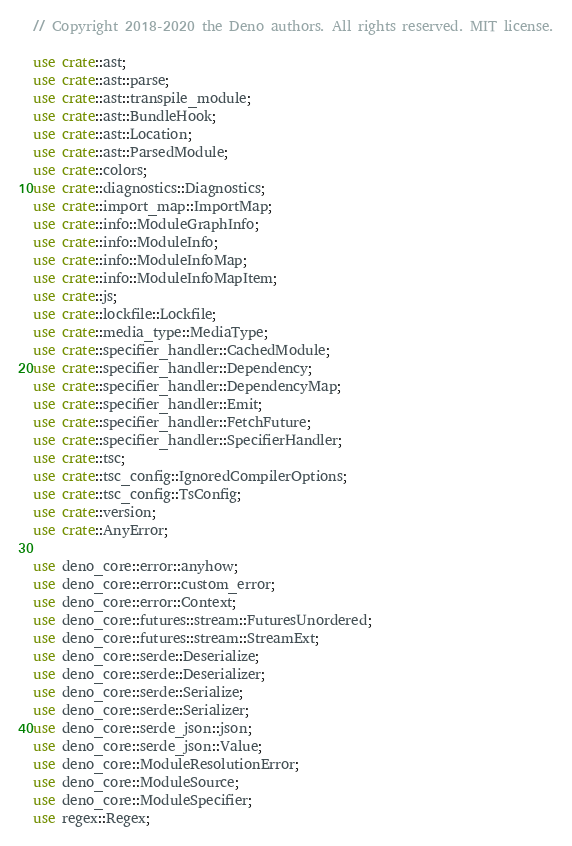Convert code to text. <code><loc_0><loc_0><loc_500><loc_500><_Rust_>// Copyright 2018-2020 the Deno authors. All rights reserved. MIT license.

use crate::ast;
use crate::ast::parse;
use crate::ast::transpile_module;
use crate::ast::BundleHook;
use crate::ast::Location;
use crate::ast::ParsedModule;
use crate::colors;
use crate::diagnostics::Diagnostics;
use crate::import_map::ImportMap;
use crate::info::ModuleGraphInfo;
use crate::info::ModuleInfo;
use crate::info::ModuleInfoMap;
use crate::info::ModuleInfoMapItem;
use crate::js;
use crate::lockfile::Lockfile;
use crate::media_type::MediaType;
use crate::specifier_handler::CachedModule;
use crate::specifier_handler::Dependency;
use crate::specifier_handler::DependencyMap;
use crate::specifier_handler::Emit;
use crate::specifier_handler::FetchFuture;
use crate::specifier_handler::SpecifierHandler;
use crate::tsc;
use crate::tsc_config::IgnoredCompilerOptions;
use crate::tsc_config::TsConfig;
use crate::version;
use crate::AnyError;

use deno_core::error::anyhow;
use deno_core::error::custom_error;
use deno_core::error::Context;
use deno_core::futures::stream::FuturesUnordered;
use deno_core::futures::stream::StreamExt;
use deno_core::serde::Deserialize;
use deno_core::serde::Deserializer;
use deno_core::serde::Serialize;
use deno_core::serde::Serializer;
use deno_core::serde_json::json;
use deno_core::serde_json::Value;
use deno_core::ModuleResolutionError;
use deno_core::ModuleSource;
use deno_core::ModuleSpecifier;
use regex::Regex;</code> 